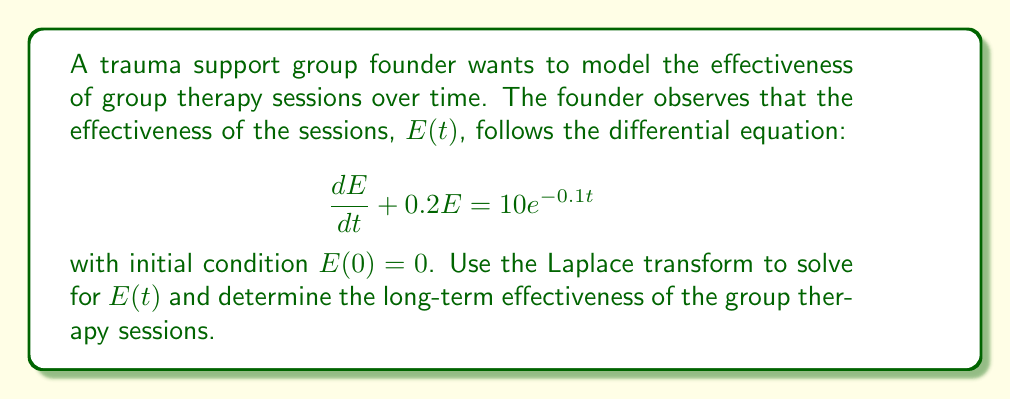Can you solve this math problem? Let's solve this problem step by step using Laplace transforms:

1) First, we take the Laplace transform of both sides of the differential equation:

   $\mathcal{L}\{\frac{dE}{dt} + 0.2E\} = \mathcal{L}\{10e^{-0.1t}\}$

2) Using the linearity property and the Laplace transform of the derivative:

   $s\mathcal{L}\{E\} - E(0) + 0.2\mathcal{L}\{E\} = \frac{10}{s+0.1}$

3) Let $\mathcal{L}\{E\} = F(s)$. Substituting $E(0) = 0$:

   $sF(s) + 0.2F(s) = \frac{10}{s+0.1}$

4) Factoring out $F(s)$:

   $F(s)(s + 0.2) = \frac{10}{s+0.1}$

5) Solving for $F(s)$:

   $F(s) = \frac{10}{(s+0.2)(s+0.1)}$

6) Using partial fraction decomposition:

   $F(s) = \frac{A}{s+0.2} + \frac{B}{s+0.1}$

   where $A = \frac{10}{0.1-0.2} = -100$ and $B = \frac{10}{0.2-0.1} = 100$

7) Therefore:

   $F(s) = \frac{-100}{s+0.2} + \frac{100}{s+0.1}$

8) Taking the inverse Laplace transform:

   $E(t) = -100e^{-0.2t} + 100e^{-0.1t}$

9) To determine the long-term effectiveness, we take the limit as $t$ approaches infinity:

   $\lim_{t\to\infty} E(t) = \lim_{t\to\infty} (-100e^{-0.2t} + 100e^{-0.1t}) = 0$

This means that in the long term, the effectiveness of the group therapy sessions approaches zero.
Answer: $E(t) = -100e^{-0.2t} + 100e^{-0.1t}$

Long-term effectiveness: $\lim_{t\to\infty} E(t) = 0$ 